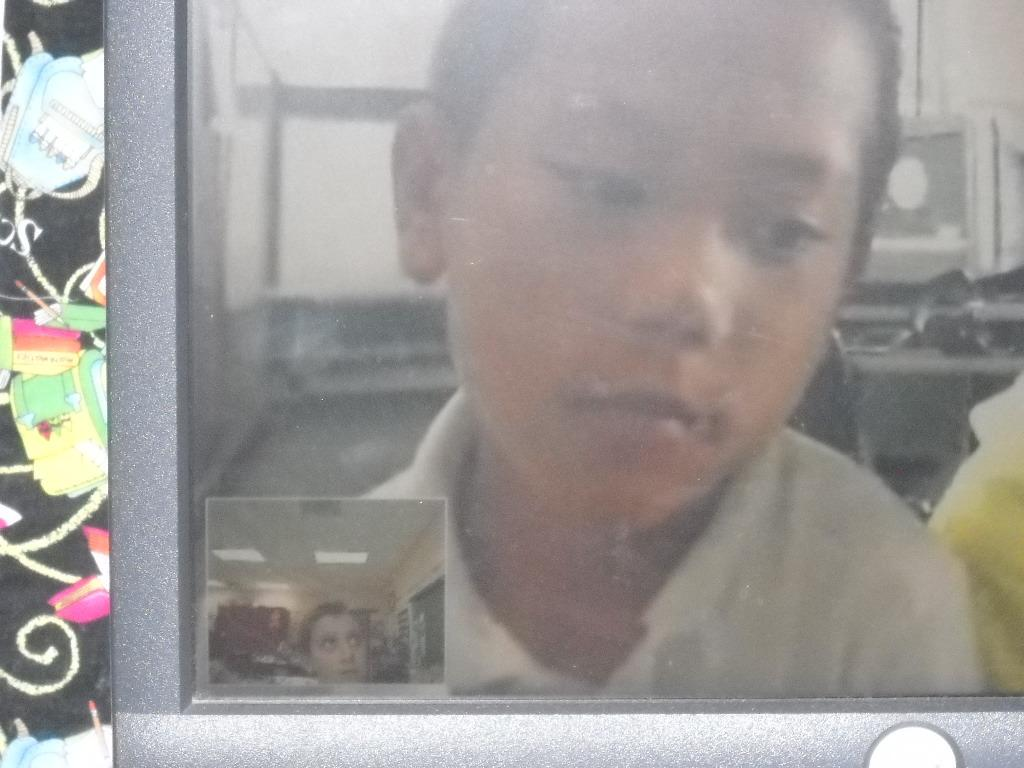What is the main subject of the image? The main subject of the image is a child. Where is the child located in the image? The child is on a monitor screen. Can you see any animals from the zoo in the image? There are no animals from the zoo present in the image; it only features a child on a monitor screen. Is there any blood visible in the image? There is no blood visible in the image; it only features a child on a monitor screen. 